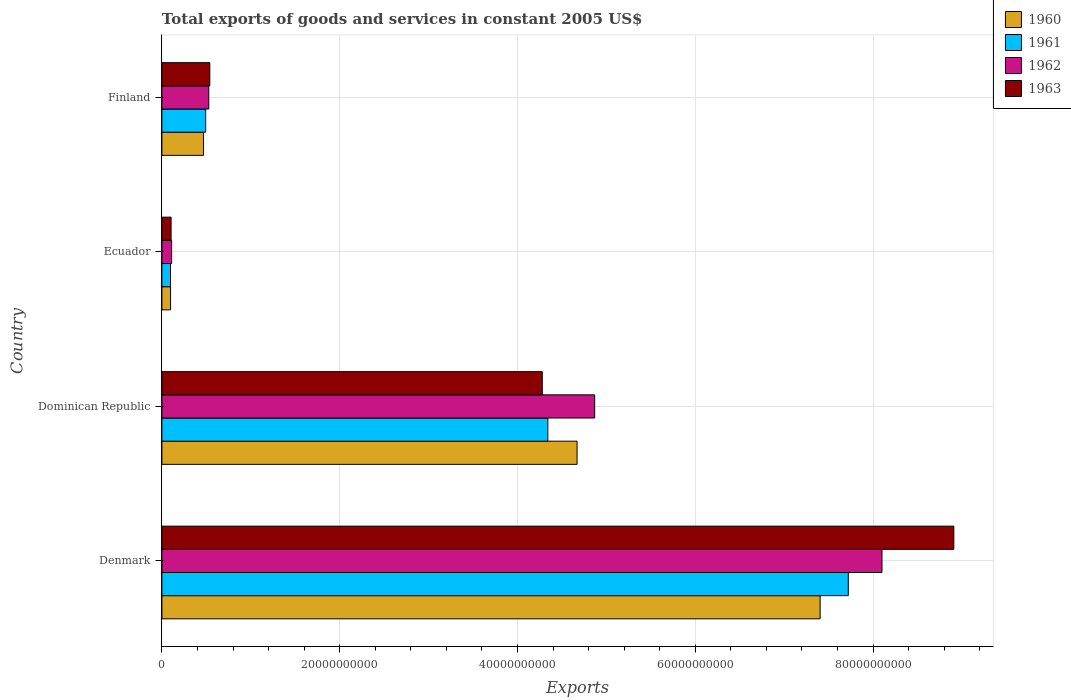How many different coloured bars are there?
Ensure brevity in your answer.  4. How many groups of bars are there?
Make the answer very short. 4. Are the number of bars on each tick of the Y-axis equal?
Make the answer very short. Yes. How many bars are there on the 1st tick from the top?
Provide a short and direct response. 4. How many bars are there on the 2nd tick from the bottom?
Your response must be concise. 4. In how many cases, is the number of bars for a given country not equal to the number of legend labels?
Give a very brief answer. 0. What is the total exports of goods and services in 1963 in Ecuador?
Keep it short and to the point. 1.03e+09. Across all countries, what is the maximum total exports of goods and services in 1960?
Keep it short and to the point. 7.40e+1. Across all countries, what is the minimum total exports of goods and services in 1960?
Your answer should be compact. 9.72e+08. In which country was the total exports of goods and services in 1963 maximum?
Provide a succinct answer. Denmark. In which country was the total exports of goods and services in 1962 minimum?
Offer a very short reply. Ecuador. What is the total total exports of goods and services in 1960 in the graph?
Offer a terse response. 1.26e+11. What is the difference between the total exports of goods and services in 1963 in Ecuador and that in Finland?
Make the answer very short. -4.36e+09. What is the difference between the total exports of goods and services in 1962 in Ecuador and the total exports of goods and services in 1960 in Finland?
Keep it short and to the point. -3.59e+09. What is the average total exports of goods and services in 1961 per country?
Your response must be concise. 3.16e+1. What is the difference between the total exports of goods and services in 1963 and total exports of goods and services in 1960 in Dominican Republic?
Offer a very short reply. -3.92e+09. What is the ratio of the total exports of goods and services in 1960 in Dominican Republic to that in Ecuador?
Ensure brevity in your answer.  48.04. Is the difference between the total exports of goods and services in 1963 in Ecuador and Finland greater than the difference between the total exports of goods and services in 1960 in Ecuador and Finland?
Offer a terse response. No. What is the difference between the highest and the second highest total exports of goods and services in 1960?
Ensure brevity in your answer.  2.73e+1. What is the difference between the highest and the lowest total exports of goods and services in 1960?
Provide a succinct answer. 7.31e+1. Is the sum of the total exports of goods and services in 1960 in Dominican Republic and Finland greater than the maximum total exports of goods and services in 1963 across all countries?
Provide a succinct answer. No. What does the 1st bar from the bottom in Dominican Republic represents?
Offer a terse response. 1960. Is it the case that in every country, the sum of the total exports of goods and services in 1961 and total exports of goods and services in 1963 is greater than the total exports of goods and services in 1960?
Your answer should be compact. Yes. How many bars are there?
Give a very brief answer. 16. How many countries are there in the graph?
Your answer should be very brief. 4. Are the values on the major ticks of X-axis written in scientific E-notation?
Keep it short and to the point. No. Does the graph contain any zero values?
Ensure brevity in your answer.  No. Does the graph contain grids?
Your answer should be very brief. Yes. Where does the legend appear in the graph?
Your answer should be very brief. Top right. How many legend labels are there?
Offer a terse response. 4. What is the title of the graph?
Provide a short and direct response. Total exports of goods and services in constant 2005 US$. What is the label or title of the X-axis?
Give a very brief answer. Exports. What is the Exports in 1960 in Denmark?
Keep it short and to the point. 7.40e+1. What is the Exports in 1961 in Denmark?
Offer a terse response. 7.72e+1. What is the Exports in 1962 in Denmark?
Your answer should be very brief. 8.10e+1. What is the Exports of 1963 in Denmark?
Provide a succinct answer. 8.91e+1. What is the Exports in 1960 in Dominican Republic?
Your answer should be compact. 4.67e+1. What is the Exports in 1961 in Dominican Republic?
Make the answer very short. 4.34e+1. What is the Exports of 1962 in Dominican Republic?
Give a very brief answer. 4.87e+1. What is the Exports of 1963 in Dominican Republic?
Provide a succinct answer. 4.28e+1. What is the Exports in 1960 in Ecuador?
Your answer should be compact. 9.72e+08. What is the Exports of 1961 in Ecuador?
Your answer should be compact. 9.65e+08. What is the Exports of 1962 in Ecuador?
Provide a short and direct response. 1.09e+09. What is the Exports in 1963 in Ecuador?
Keep it short and to the point. 1.03e+09. What is the Exports in 1960 in Finland?
Your answer should be compact. 4.68e+09. What is the Exports in 1961 in Finland?
Provide a succinct answer. 4.92e+09. What is the Exports in 1962 in Finland?
Offer a terse response. 5.27e+09. What is the Exports in 1963 in Finland?
Ensure brevity in your answer.  5.39e+09. Across all countries, what is the maximum Exports of 1960?
Provide a short and direct response. 7.40e+1. Across all countries, what is the maximum Exports of 1961?
Provide a short and direct response. 7.72e+1. Across all countries, what is the maximum Exports in 1962?
Keep it short and to the point. 8.10e+1. Across all countries, what is the maximum Exports of 1963?
Your answer should be compact. 8.91e+1. Across all countries, what is the minimum Exports in 1960?
Ensure brevity in your answer.  9.72e+08. Across all countries, what is the minimum Exports in 1961?
Offer a very short reply. 9.65e+08. Across all countries, what is the minimum Exports of 1962?
Give a very brief answer. 1.09e+09. Across all countries, what is the minimum Exports of 1963?
Give a very brief answer. 1.03e+09. What is the total Exports in 1960 in the graph?
Keep it short and to the point. 1.26e+11. What is the total Exports in 1961 in the graph?
Your answer should be very brief. 1.27e+11. What is the total Exports of 1962 in the graph?
Your response must be concise. 1.36e+11. What is the total Exports in 1963 in the graph?
Make the answer very short. 1.38e+11. What is the difference between the Exports of 1960 in Denmark and that in Dominican Republic?
Provide a short and direct response. 2.73e+1. What is the difference between the Exports in 1961 in Denmark and that in Dominican Republic?
Make the answer very short. 3.38e+1. What is the difference between the Exports in 1962 in Denmark and that in Dominican Republic?
Your response must be concise. 3.23e+1. What is the difference between the Exports of 1963 in Denmark and that in Dominican Republic?
Provide a succinct answer. 4.63e+1. What is the difference between the Exports of 1960 in Denmark and that in Ecuador?
Provide a short and direct response. 7.31e+1. What is the difference between the Exports in 1961 in Denmark and that in Ecuador?
Your answer should be very brief. 7.62e+1. What is the difference between the Exports of 1962 in Denmark and that in Ecuador?
Make the answer very short. 7.99e+1. What is the difference between the Exports of 1963 in Denmark and that in Ecuador?
Give a very brief answer. 8.81e+1. What is the difference between the Exports in 1960 in Denmark and that in Finland?
Ensure brevity in your answer.  6.94e+1. What is the difference between the Exports of 1961 in Denmark and that in Finland?
Your answer should be very brief. 7.23e+1. What is the difference between the Exports of 1962 in Denmark and that in Finland?
Make the answer very short. 7.57e+1. What is the difference between the Exports in 1963 in Denmark and that in Finland?
Your answer should be very brief. 8.37e+1. What is the difference between the Exports in 1960 in Dominican Republic and that in Ecuador?
Ensure brevity in your answer.  4.57e+1. What is the difference between the Exports in 1961 in Dominican Republic and that in Ecuador?
Your answer should be compact. 4.25e+1. What is the difference between the Exports in 1962 in Dominican Republic and that in Ecuador?
Ensure brevity in your answer.  4.76e+1. What is the difference between the Exports of 1963 in Dominican Republic and that in Ecuador?
Provide a succinct answer. 4.18e+1. What is the difference between the Exports in 1960 in Dominican Republic and that in Finland?
Provide a short and direct response. 4.20e+1. What is the difference between the Exports in 1961 in Dominican Republic and that in Finland?
Your response must be concise. 3.85e+1. What is the difference between the Exports in 1962 in Dominican Republic and that in Finland?
Provide a short and direct response. 4.34e+1. What is the difference between the Exports of 1963 in Dominican Republic and that in Finland?
Your answer should be very brief. 3.74e+1. What is the difference between the Exports in 1960 in Ecuador and that in Finland?
Offer a terse response. -3.71e+09. What is the difference between the Exports of 1961 in Ecuador and that in Finland?
Your answer should be very brief. -3.96e+09. What is the difference between the Exports of 1962 in Ecuador and that in Finland?
Provide a succinct answer. -4.18e+09. What is the difference between the Exports of 1963 in Ecuador and that in Finland?
Make the answer very short. -4.36e+09. What is the difference between the Exports in 1960 in Denmark and the Exports in 1961 in Dominican Republic?
Your response must be concise. 3.06e+1. What is the difference between the Exports in 1960 in Denmark and the Exports in 1962 in Dominican Republic?
Your answer should be very brief. 2.54e+1. What is the difference between the Exports in 1960 in Denmark and the Exports in 1963 in Dominican Republic?
Offer a very short reply. 3.13e+1. What is the difference between the Exports in 1961 in Denmark and the Exports in 1962 in Dominican Republic?
Provide a succinct answer. 2.85e+1. What is the difference between the Exports of 1961 in Denmark and the Exports of 1963 in Dominican Republic?
Offer a terse response. 3.44e+1. What is the difference between the Exports of 1962 in Denmark and the Exports of 1963 in Dominican Republic?
Give a very brief answer. 3.82e+1. What is the difference between the Exports of 1960 in Denmark and the Exports of 1961 in Ecuador?
Provide a short and direct response. 7.31e+1. What is the difference between the Exports of 1960 in Denmark and the Exports of 1962 in Ecuador?
Your response must be concise. 7.30e+1. What is the difference between the Exports in 1960 in Denmark and the Exports in 1963 in Ecuador?
Give a very brief answer. 7.30e+1. What is the difference between the Exports of 1961 in Denmark and the Exports of 1962 in Ecuador?
Keep it short and to the point. 7.61e+1. What is the difference between the Exports of 1961 in Denmark and the Exports of 1963 in Ecuador?
Ensure brevity in your answer.  7.62e+1. What is the difference between the Exports of 1962 in Denmark and the Exports of 1963 in Ecuador?
Give a very brief answer. 8.00e+1. What is the difference between the Exports in 1960 in Denmark and the Exports in 1961 in Finland?
Offer a terse response. 6.91e+1. What is the difference between the Exports of 1960 in Denmark and the Exports of 1962 in Finland?
Offer a very short reply. 6.88e+1. What is the difference between the Exports of 1960 in Denmark and the Exports of 1963 in Finland?
Provide a succinct answer. 6.87e+1. What is the difference between the Exports in 1961 in Denmark and the Exports in 1962 in Finland?
Make the answer very short. 7.19e+1. What is the difference between the Exports in 1961 in Denmark and the Exports in 1963 in Finland?
Make the answer very short. 7.18e+1. What is the difference between the Exports in 1962 in Denmark and the Exports in 1963 in Finland?
Give a very brief answer. 7.56e+1. What is the difference between the Exports of 1960 in Dominican Republic and the Exports of 1961 in Ecuador?
Your answer should be very brief. 4.57e+1. What is the difference between the Exports in 1960 in Dominican Republic and the Exports in 1962 in Ecuador?
Offer a terse response. 4.56e+1. What is the difference between the Exports of 1960 in Dominican Republic and the Exports of 1963 in Ecuador?
Give a very brief answer. 4.57e+1. What is the difference between the Exports in 1961 in Dominican Republic and the Exports in 1962 in Ecuador?
Offer a very short reply. 4.23e+1. What is the difference between the Exports of 1961 in Dominican Republic and the Exports of 1963 in Ecuador?
Keep it short and to the point. 4.24e+1. What is the difference between the Exports in 1962 in Dominican Republic and the Exports in 1963 in Ecuador?
Keep it short and to the point. 4.77e+1. What is the difference between the Exports in 1960 in Dominican Republic and the Exports in 1961 in Finland?
Keep it short and to the point. 4.18e+1. What is the difference between the Exports of 1960 in Dominican Republic and the Exports of 1962 in Finland?
Ensure brevity in your answer.  4.14e+1. What is the difference between the Exports in 1960 in Dominican Republic and the Exports in 1963 in Finland?
Give a very brief answer. 4.13e+1. What is the difference between the Exports of 1961 in Dominican Republic and the Exports of 1962 in Finland?
Ensure brevity in your answer.  3.81e+1. What is the difference between the Exports in 1961 in Dominican Republic and the Exports in 1963 in Finland?
Your answer should be very brief. 3.80e+1. What is the difference between the Exports in 1962 in Dominican Republic and the Exports in 1963 in Finland?
Your response must be concise. 4.33e+1. What is the difference between the Exports in 1960 in Ecuador and the Exports in 1961 in Finland?
Keep it short and to the point. -3.95e+09. What is the difference between the Exports in 1960 in Ecuador and the Exports in 1962 in Finland?
Your answer should be compact. -4.30e+09. What is the difference between the Exports in 1960 in Ecuador and the Exports in 1963 in Finland?
Your answer should be compact. -4.41e+09. What is the difference between the Exports in 1961 in Ecuador and the Exports in 1962 in Finland?
Offer a terse response. -4.31e+09. What is the difference between the Exports of 1961 in Ecuador and the Exports of 1963 in Finland?
Provide a succinct answer. -4.42e+09. What is the difference between the Exports of 1962 in Ecuador and the Exports of 1963 in Finland?
Offer a terse response. -4.29e+09. What is the average Exports of 1960 per country?
Provide a short and direct response. 3.16e+1. What is the average Exports in 1961 per country?
Your response must be concise. 3.16e+1. What is the average Exports in 1962 per country?
Give a very brief answer. 3.40e+1. What is the average Exports in 1963 per country?
Your answer should be very brief. 3.46e+1. What is the difference between the Exports of 1960 and Exports of 1961 in Denmark?
Provide a short and direct response. -3.17e+09. What is the difference between the Exports of 1960 and Exports of 1962 in Denmark?
Your response must be concise. -6.96e+09. What is the difference between the Exports of 1960 and Exports of 1963 in Denmark?
Your answer should be very brief. -1.50e+1. What is the difference between the Exports in 1961 and Exports in 1962 in Denmark?
Offer a terse response. -3.79e+09. What is the difference between the Exports in 1961 and Exports in 1963 in Denmark?
Your answer should be very brief. -1.19e+1. What is the difference between the Exports in 1962 and Exports in 1963 in Denmark?
Your answer should be very brief. -8.08e+09. What is the difference between the Exports of 1960 and Exports of 1961 in Dominican Republic?
Offer a very short reply. 3.29e+09. What is the difference between the Exports of 1960 and Exports of 1962 in Dominican Republic?
Provide a short and direct response. -1.98e+09. What is the difference between the Exports in 1960 and Exports in 1963 in Dominican Republic?
Your answer should be compact. 3.92e+09. What is the difference between the Exports of 1961 and Exports of 1962 in Dominican Republic?
Offer a very short reply. -5.27e+09. What is the difference between the Exports in 1961 and Exports in 1963 in Dominican Republic?
Give a very brief answer. 6.26e+08. What is the difference between the Exports in 1962 and Exports in 1963 in Dominican Republic?
Your response must be concise. 5.89e+09. What is the difference between the Exports in 1960 and Exports in 1961 in Ecuador?
Your answer should be compact. 7.18e+06. What is the difference between the Exports in 1960 and Exports in 1962 in Ecuador?
Ensure brevity in your answer.  -1.22e+08. What is the difference between the Exports in 1960 and Exports in 1963 in Ecuador?
Your response must be concise. -5.99e+07. What is the difference between the Exports in 1961 and Exports in 1962 in Ecuador?
Give a very brief answer. -1.29e+08. What is the difference between the Exports in 1961 and Exports in 1963 in Ecuador?
Keep it short and to the point. -6.70e+07. What is the difference between the Exports of 1962 and Exports of 1963 in Ecuador?
Give a very brief answer. 6.23e+07. What is the difference between the Exports of 1960 and Exports of 1961 in Finland?
Your response must be concise. -2.41e+08. What is the difference between the Exports of 1960 and Exports of 1962 in Finland?
Offer a very short reply. -5.89e+08. What is the difference between the Exports of 1960 and Exports of 1963 in Finland?
Keep it short and to the point. -7.04e+08. What is the difference between the Exports of 1961 and Exports of 1962 in Finland?
Give a very brief answer. -3.48e+08. What is the difference between the Exports of 1961 and Exports of 1963 in Finland?
Make the answer very short. -4.64e+08. What is the difference between the Exports of 1962 and Exports of 1963 in Finland?
Your response must be concise. -1.15e+08. What is the ratio of the Exports of 1960 in Denmark to that in Dominican Republic?
Offer a very short reply. 1.59. What is the ratio of the Exports in 1961 in Denmark to that in Dominican Republic?
Your response must be concise. 1.78. What is the ratio of the Exports in 1962 in Denmark to that in Dominican Republic?
Provide a succinct answer. 1.66. What is the ratio of the Exports in 1963 in Denmark to that in Dominican Republic?
Give a very brief answer. 2.08. What is the ratio of the Exports of 1960 in Denmark to that in Ecuador?
Your response must be concise. 76.17. What is the ratio of the Exports of 1961 in Denmark to that in Ecuador?
Your answer should be very brief. 80.01. What is the ratio of the Exports of 1962 in Denmark to that in Ecuador?
Give a very brief answer. 74.02. What is the ratio of the Exports in 1963 in Denmark to that in Ecuador?
Your answer should be very brief. 86.32. What is the ratio of the Exports in 1960 in Denmark to that in Finland?
Give a very brief answer. 15.81. What is the ratio of the Exports in 1961 in Denmark to that in Finland?
Provide a succinct answer. 15.68. What is the ratio of the Exports in 1962 in Denmark to that in Finland?
Your answer should be very brief. 15.37. What is the ratio of the Exports of 1963 in Denmark to that in Finland?
Your answer should be compact. 16.54. What is the ratio of the Exports in 1960 in Dominican Republic to that in Ecuador?
Offer a very short reply. 48.04. What is the ratio of the Exports in 1961 in Dominican Republic to that in Ecuador?
Offer a terse response. 44.99. What is the ratio of the Exports in 1962 in Dominican Republic to that in Ecuador?
Your response must be concise. 44.49. What is the ratio of the Exports in 1963 in Dominican Republic to that in Ecuador?
Keep it short and to the point. 41.46. What is the ratio of the Exports of 1960 in Dominican Republic to that in Finland?
Give a very brief answer. 9.97. What is the ratio of the Exports in 1961 in Dominican Republic to that in Finland?
Ensure brevity in your answer.  8.82. What is the ratio of the Exports of 1962 in Dominican Republic to that in Finland?
Keep it short and to the point. 9.23. What is the ratio of the Exports in 1963 in Dominican Republic to that in Finland?
Offer a terse response. 7.94. What is the ratio of the Exports in 1960 in Ecuador to that in Finland?
Give a very brief answer. 0.21. What is the ratio of the Exports of 1961 in Ecuador to that in Finland?
Keep it short and to the point. 0.2. What is the ratio of the Exports of 1962 in Ecuador to that in Finland?
Your response must be concise. 0.21. What is the ratio of the Exports of 1963 in Ecuador to that in Finland?
Ensure brevity in your answer.  0.19. What is the difference between the highest and the second highest Exports of 1960?
Offer a very short reply. 2.73e+1. What is the difference between the highest and the second highest Exports of 1961?
Ensure brevity in your answer.  3.38e+1. What is the difference between the highest and the second highest Exports of 1962?
Provide a succinct answer. 3.23e+1. What is the difference between the highest and the second highest Exports of 1963?
Your response must be concise. 4.63e+1. What is the difference between the highest and the lowest Exports in 1960?
Your response must be concise. 7.31e+1. What is the difference between the highest and the lowest Exports in 1961?
Make the answer very short. 7.62e+1. What is the difference between the highest and the lowest Exports of 1962?
Give a very brief answer. 7.99e+1. What is the difference between the highest and the lowest Exports of 1963?
Keep it short and to the point. 8.81e+1. 